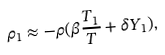Convert formula to latex. <formula><loc_0><loc_0><loc_500><loc_500>\rho _ { 1 } \approx - \rho ( \beta \frac { T _ { 1 } } { T } + \delta Y _ { 1 } ) ,</formula> 